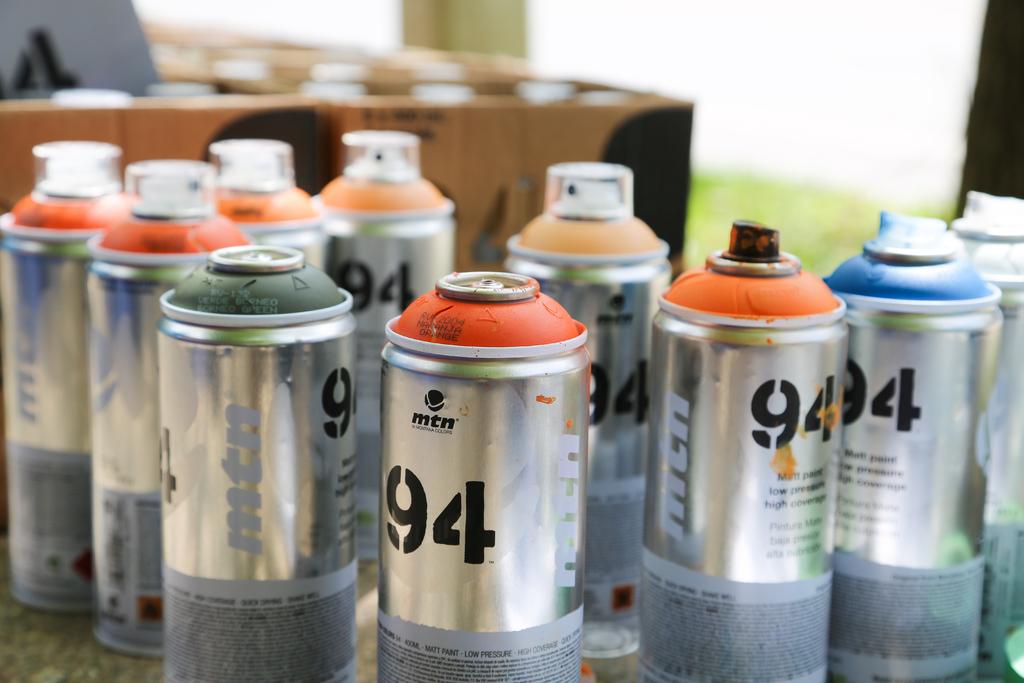What number is on the spray bottles?
Provide a succinct answer. 94. What are the white letters on the can?
Your response must be concise. Mtn. 